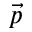<formula> <loc_0><loc_0><loc_500><loc_500>\vec { p }</formula> 